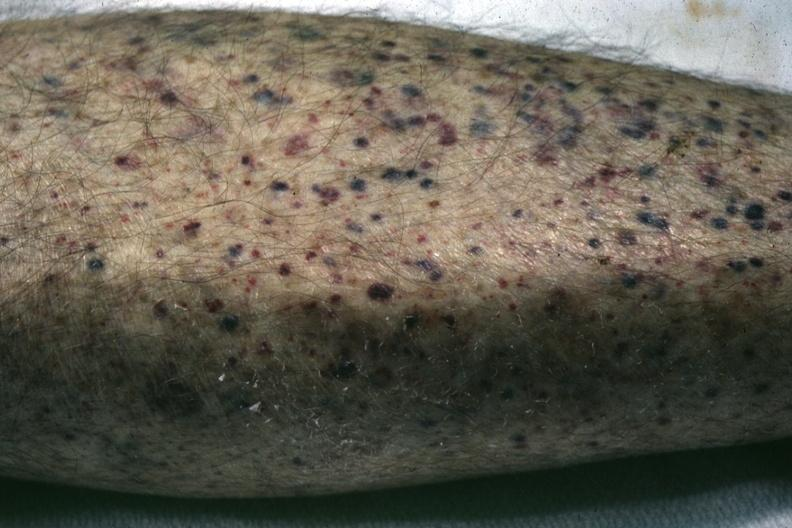what is present?
Answer the question using a single word or phrase. Petechial and purpuric hemorrhages 